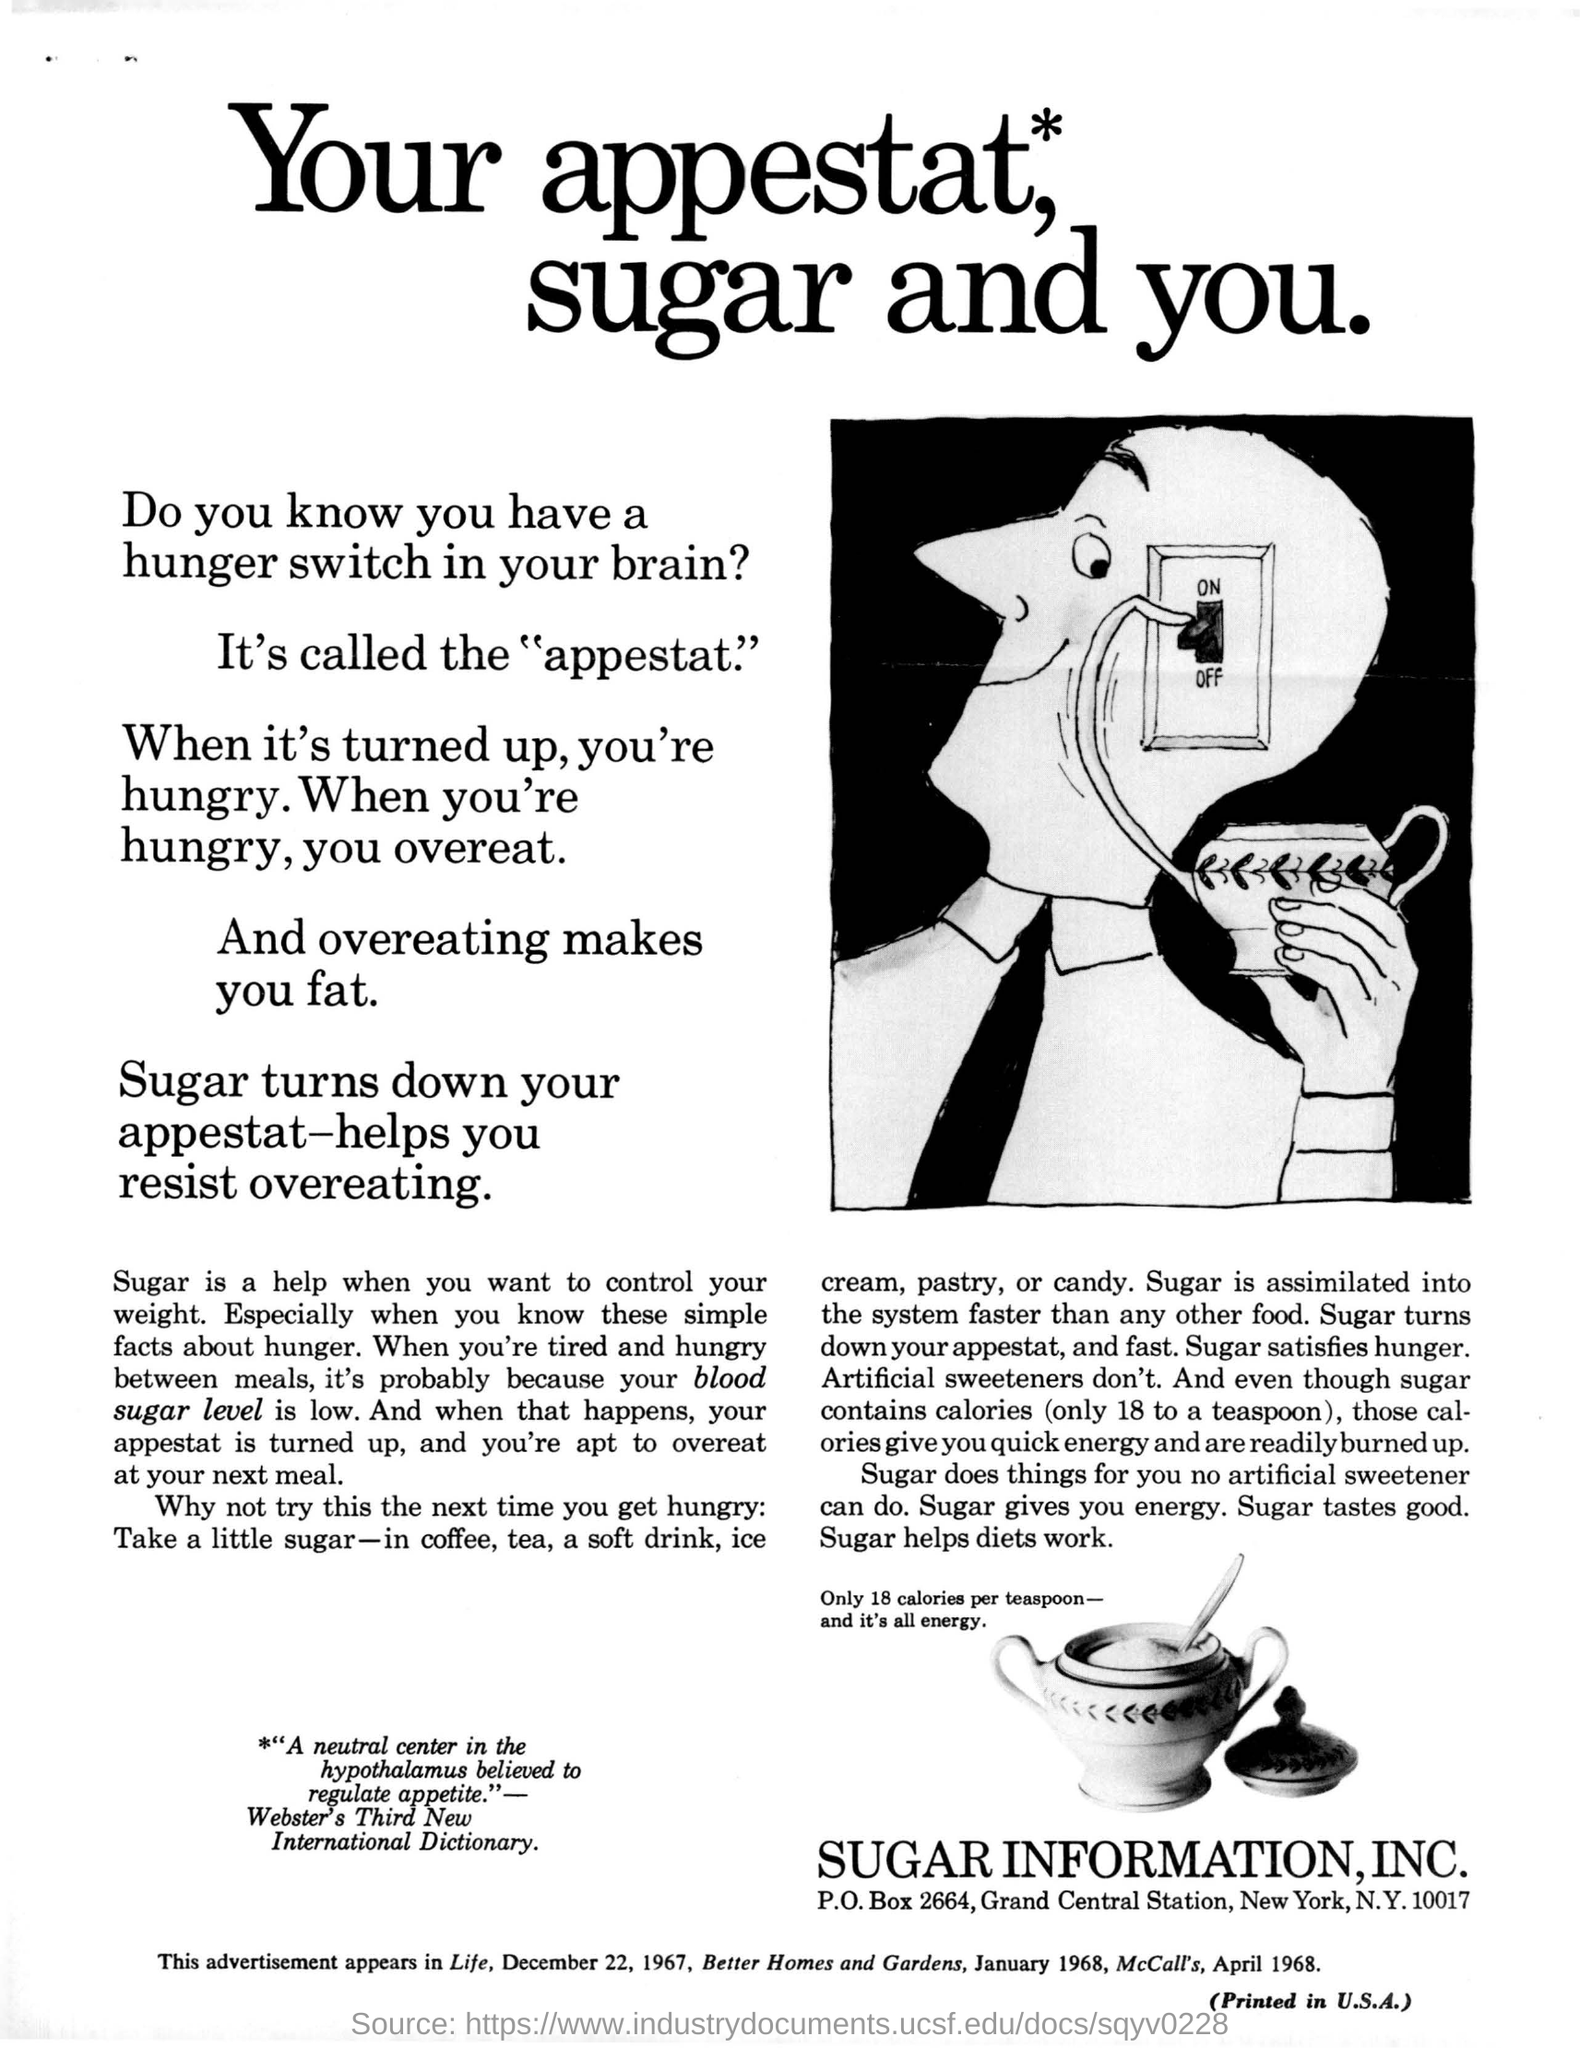What does the hunger switch in your brain called as ?
Ensure brevity in your answer.  Appestat. How many calories does a teaspoon of sugar contain ?
Your answer should be compact. 18 calories per teaspoon. What is the address given for sugar information,inc.?
Provide a short and direct response. P.o.box 2664,grand central station, new york,n.y.10017. 